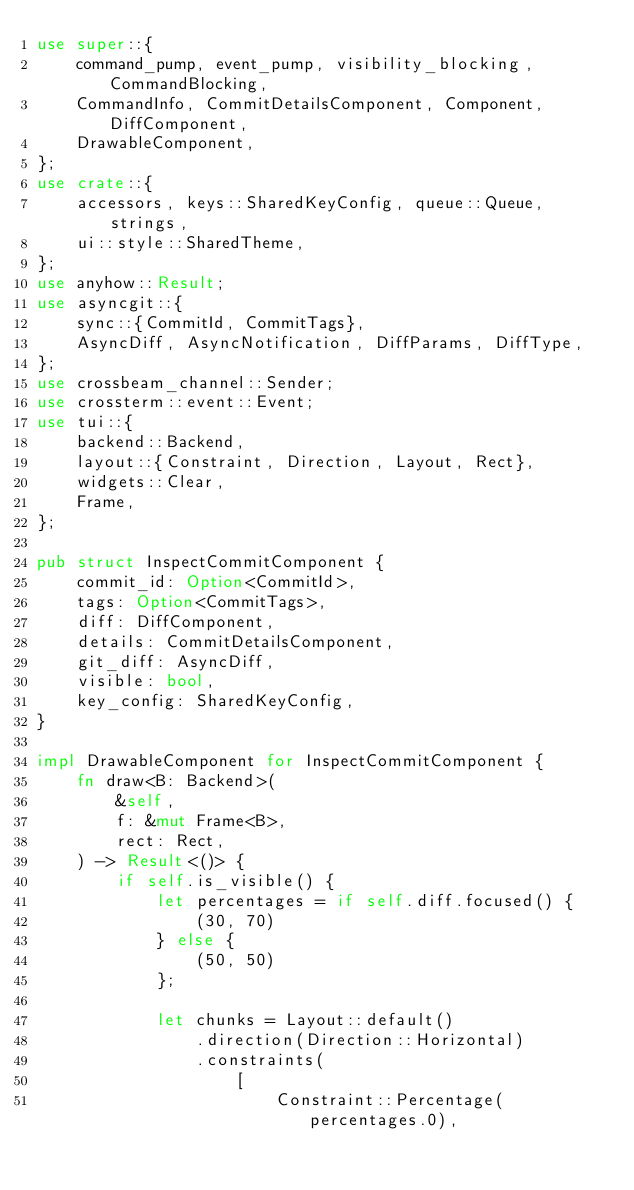<code> <loc_0><loc_0><loc_500><loc_500><_Rust_>use super::{
    command_pump, event_pump, visibility_blocking, CommandBlocking,
    CommandInfo, CommitDetailsComponent, Component, DiffComponent,
    DrawableComponent,
};
use crate::{
    accessors, keys::SharedKeyConfig, queue::Queue, strings,
    ui::style::SharedTheme,
};
use anyhow::Result;
use asyncgit::{
    sync::{CommitId, CommitTags},
    AsyncDiff, AsyncNotification, DiffParams, DiffType,
};
use crossbeam_channel::Sender;
use crossterm::event::Event;
use tui::{
    backend::Backend,
    layout::{Constraint, Direction, Layout, Rect},
    widgets::Clear,
    Frame,
};

pub struct InspectCommitComponent {
    commit_id: Option<CommitId>,
    tags: Option<CommitTags>,
    diff: DiffComponent,
    details: CommitDetailsComponent,
    git_diff: AsyncDiff,
    visible: bool,
    key_config: SharedKeyConfig,
}

impl DrawableComponent for InspectCommitComponent {
    fn draw<B: Backend>(
        &self,
        f: &mut Frame<B>,
        rect: Rect,
    ) -> Result<()> {
        if self.is_visible() {
            let percentages = if self.diff.focused() {
                (30, 70)
            } else {
                (50, 50)
            };

            let chunks = Layout::default()
                .direction(Direction::Horizontal)
                .constraints(
                    [
                        Constraint::Percentage(percentages.0),</code> 